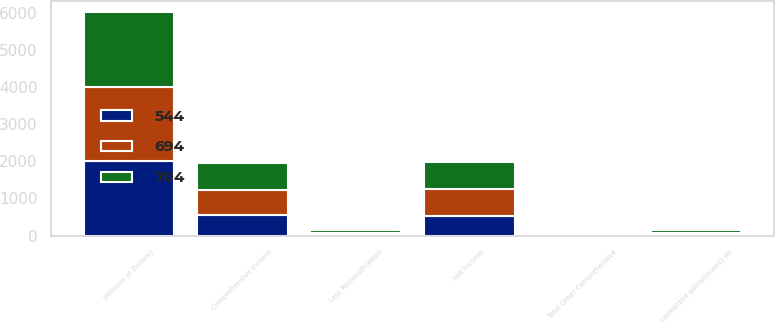<chart> <loc_0><loc_0><loc_500><loc_500><stacked_bar_chart><ecel><fcel>(Millions of Dollars)<fcel>Net Income<fcel>Unrealized gains/(losses) on<fcel>Less Reclassification<fcel>Total Other Comprehensive<fcel>Comprehensive Income<nl><fcel>704<fcel>2006<fcel>737<fcel>99<fcel>71<fcel>33<fcel>704<nl><fcel>694<fcel>2005<fcel>719<fcel>39<fcel>59<fcel>25<fcel>694<nl><fcel>544<fcel>2004<fcel>537<fcel>21<fcel>14<fcel>7<fcel>544<nl></chart> 